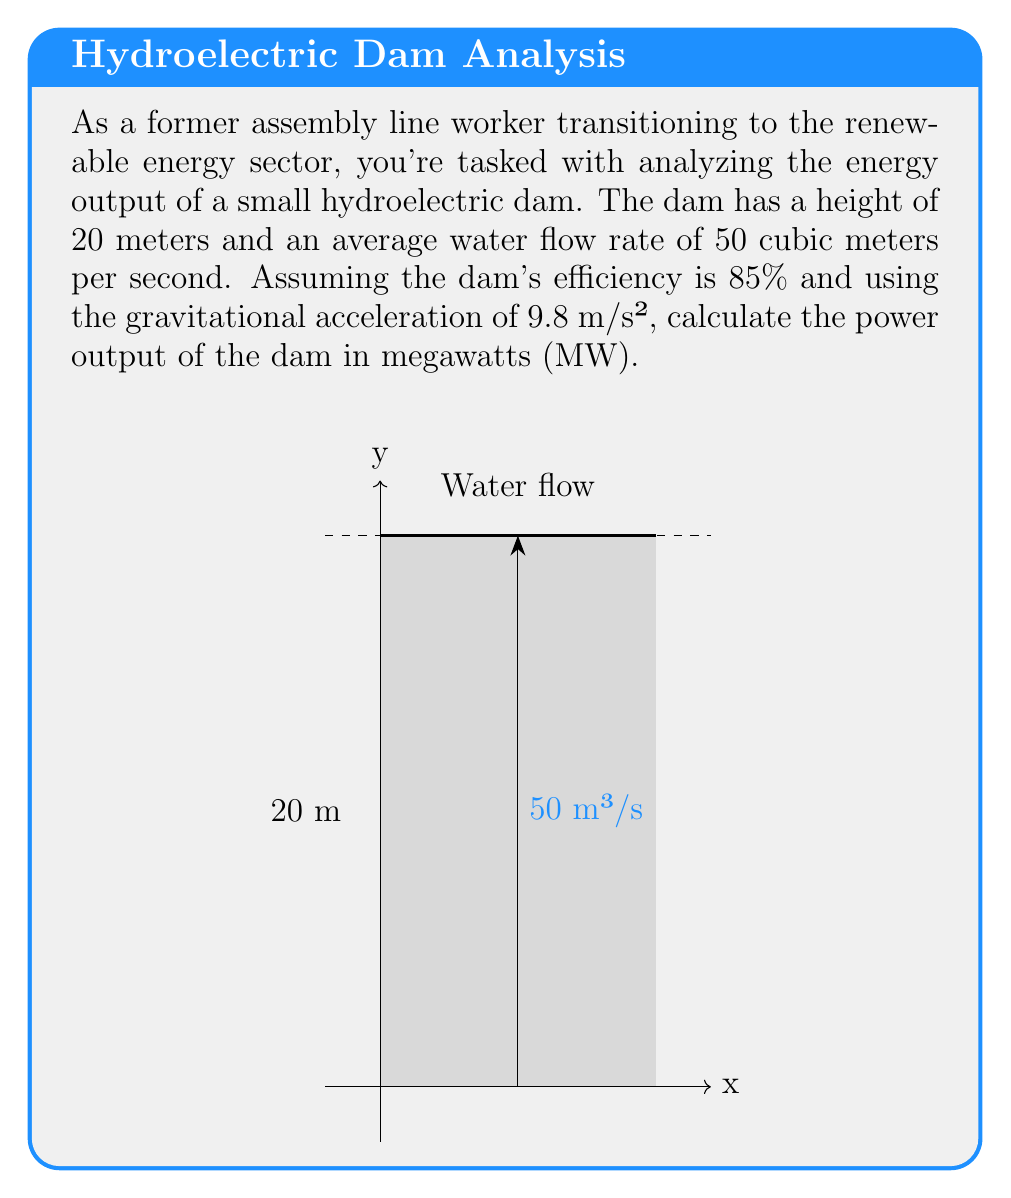Could you help me with this problem? Let's approach this step-by-step:

1) The power output of a hydroelectric dam is given by the formula:

   $$P = \eta \rho g Q h$$

   Where:
   $P$ = Power output (W)
   $\eta$ = Efficiency
   $\rho$ = Density of water (1000 kg/m³)
   $g$ = Gravitational acceleration (9.8 m/s²)
   $Q$ = Water flow rate (m³/s)
   $h$ = Height of the dam (m)

2) We're given:
   $\eta = 85\% = 0.85$
   $\rho = 1000$ kg/m³
   $g = 9.8$ m/s²
   $Q = 50$ m³/s
   $h = 20$ m

3) Let's substitute these values into our equation:

   $$P = 0.85 \times 1000 \times 9.8 \times 50 \times 20$$

4) Now, let's calculate:

   $$P = 8,330,000 \text{ W}$$

5) Convert watts to megawatts:

   $$P = 8,330,000 \text{ W} \times \frac{1 \text{ MW}}{1,000,000 \text{ W}} = 8.33 \text{ MW}$$

Thus, the power output of the dam is 8.33 MW.
Answer: 8.33 MW 